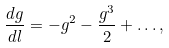<formula> <loc_0><loc_0><loc_500><loc_500>\frac { d g } { d l } = - g ^ { 2 } - \frac { g ^ { 3 } } { 2 } + \dots ,</formula> 